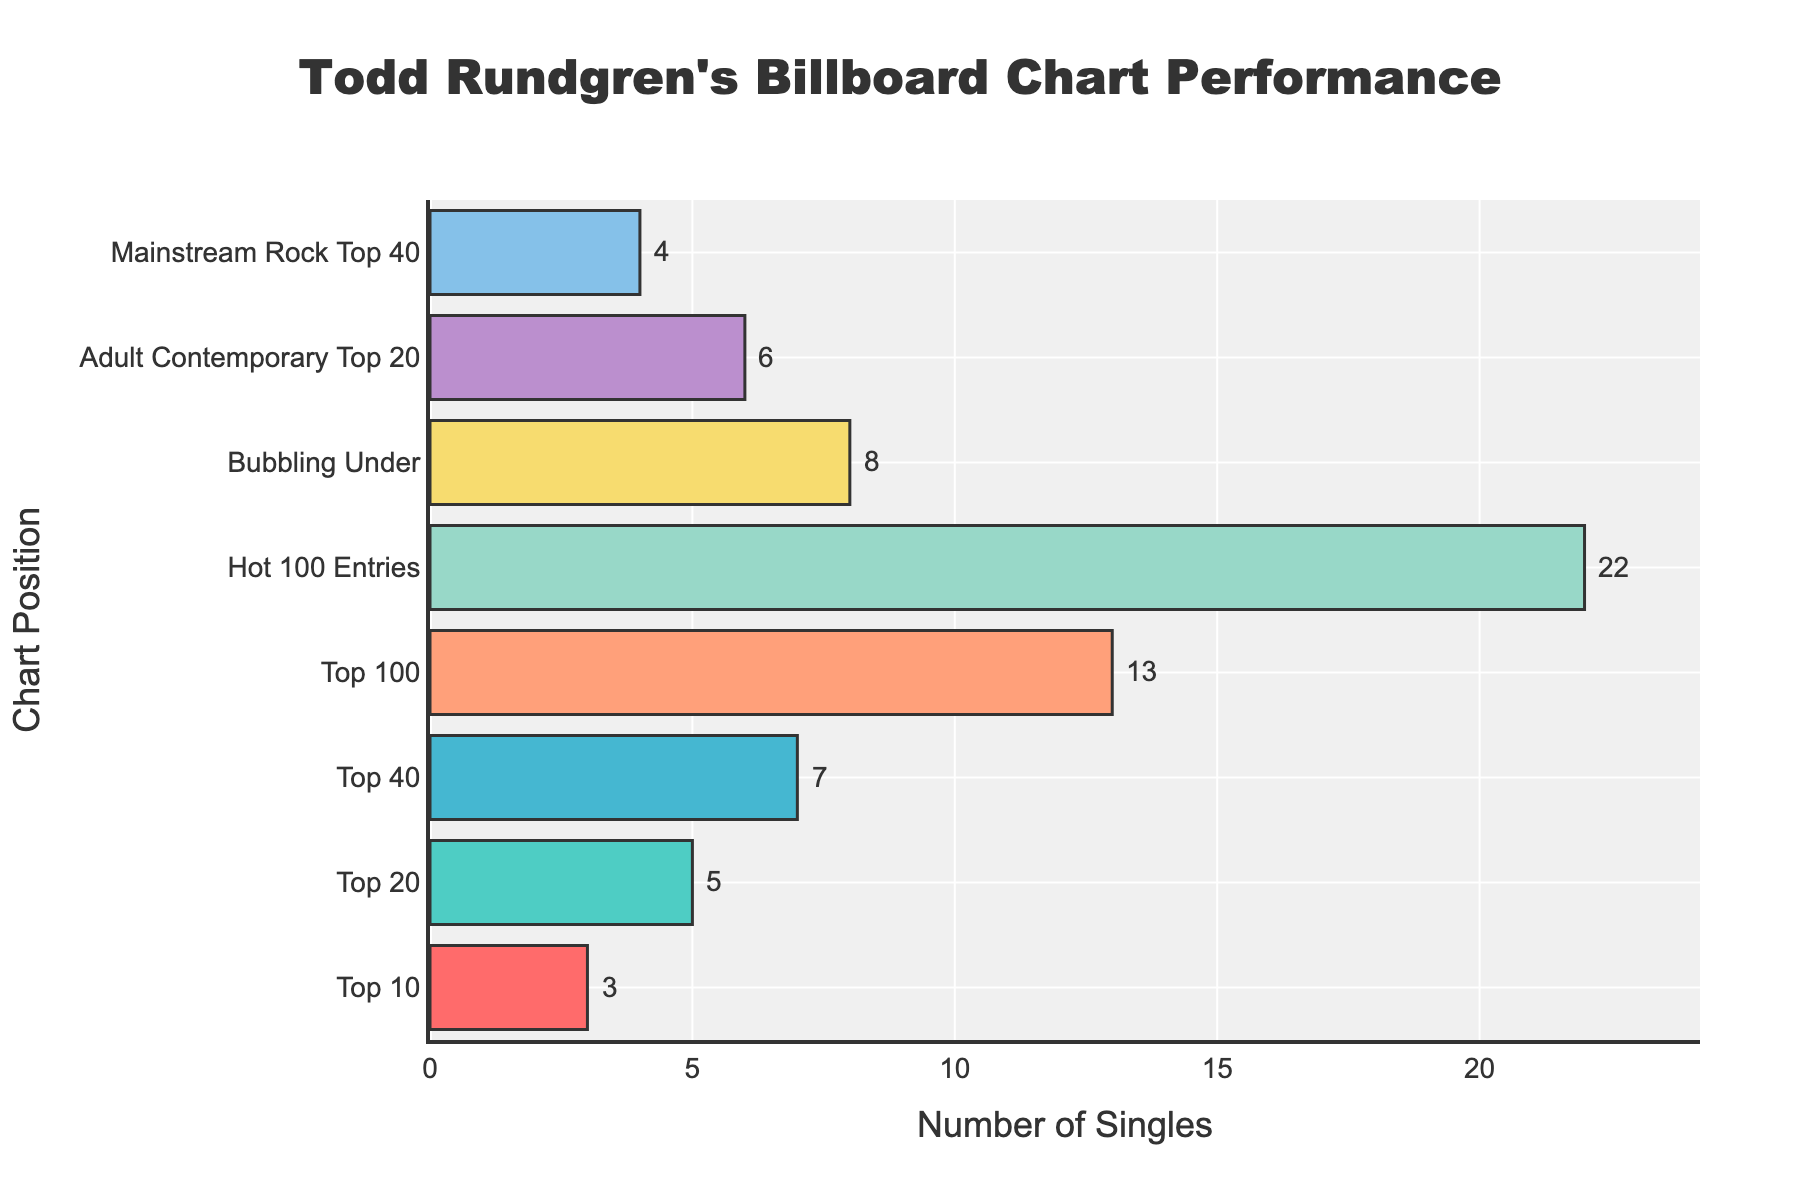How many singles made it to both the Top 10 and the Top 20? There are 3 singles in the Top 10 and 5 singles in the Top 20. Since the Top 10 is a subset of the Top 20, the total number is just the 5 singles that reached at least the Top 20.
Answer: 5 Which position group has the highest number of singles? The group with the highest number of singles is "Hot 100 Entries" with a total of 22 singles, as can be seen from the length of the bar.
Answer: Hot 100 Entries How many more singles charted in the Top 40 than in the Bubbling Under? The number of singles in the Top 40 is 7, and in the Bubbling Under, it is 8. The difference is 8 - 7 = 1.
Answer: 1 What is the total number of singles that made it to at least the Top 100? The top positions include Top 10, Top 20, Top 40, and Top 100. Summing these, we get 3 (Top 10) + 5 (Top 20) + 7 (Top 40) + 13 (Top 100) = 28.
Answer: 28 Are there more singles in the Adult Contemporary Top 20 or the Mainstream Rock Top 40? The bar for the Adult Contemporary Top 20 shows 6 singles, while the Mainstream Rock Top 40 shows 4 singles. Since 6 is greater than 4, there are more singles in the Adult Contemporary Top 20.
Answer: Adult Contemporary Top 20 What is the average number of singles across all chart positions listed? There are 8 chart positions. Summing the singles: 3 (Top 10) + 5 (Top 20) + 7 (Top 40) + 13 (Top 100) + 22 (Hot 100 Entries) + 8 (Bubbling Under) + 6 (Adult Contemporary Top 20) + 4 (Mainstream Rock Top 40) = 68. The average is 68/8 = 8.5.
Answer: 8.5 What's the difference in the number of singles between those in the Hot 100 Entries and those in the Top 10? The number of singles in the Hot 100 Entries is 22, and in the Top 10 it is 3. The difference is 22 - 3 = 19.
Answer: 19 